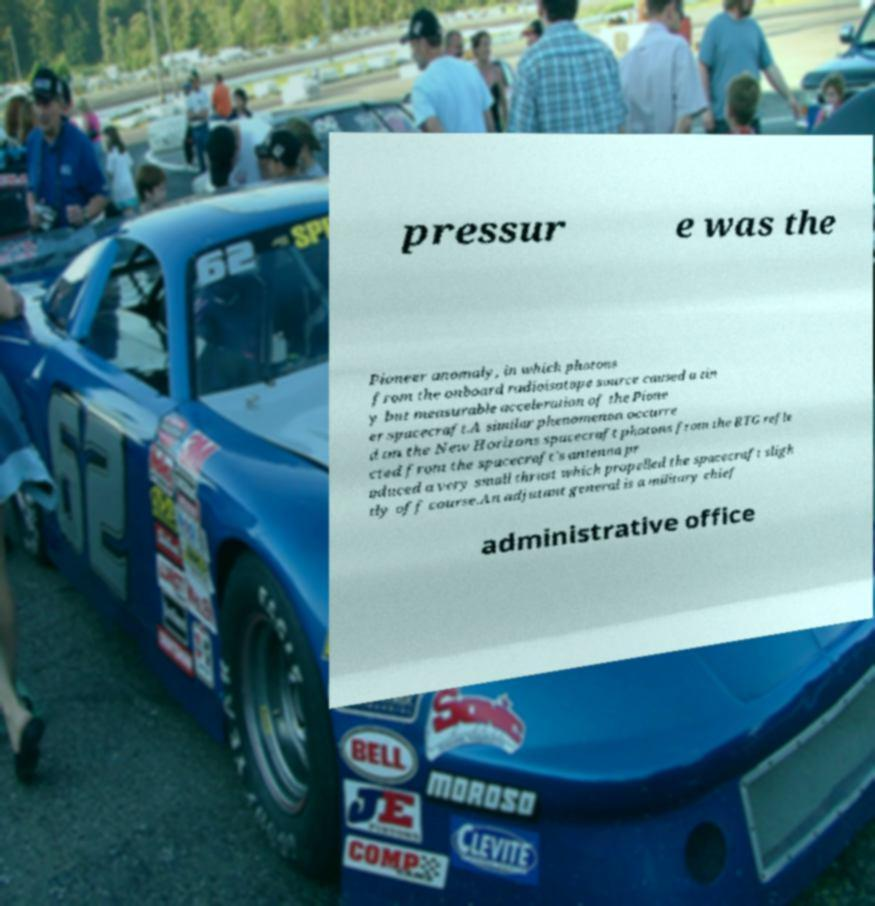I need the written content from this picture converted into text. Can you do that? pressur e was the Pioneer anomaly, in which photons from the onboard radioisotope source caused a tin y but measurable acceleration of the Pione er spacecraft.A similar phenomenon occurre d on the New Horizons spacecraft photons from the RTG refle cted from the spacecraft's antenna pr oduced a very small thrust which propelled the spacecraft sligh tly off course.An adjutant general is a military chief administrative office 